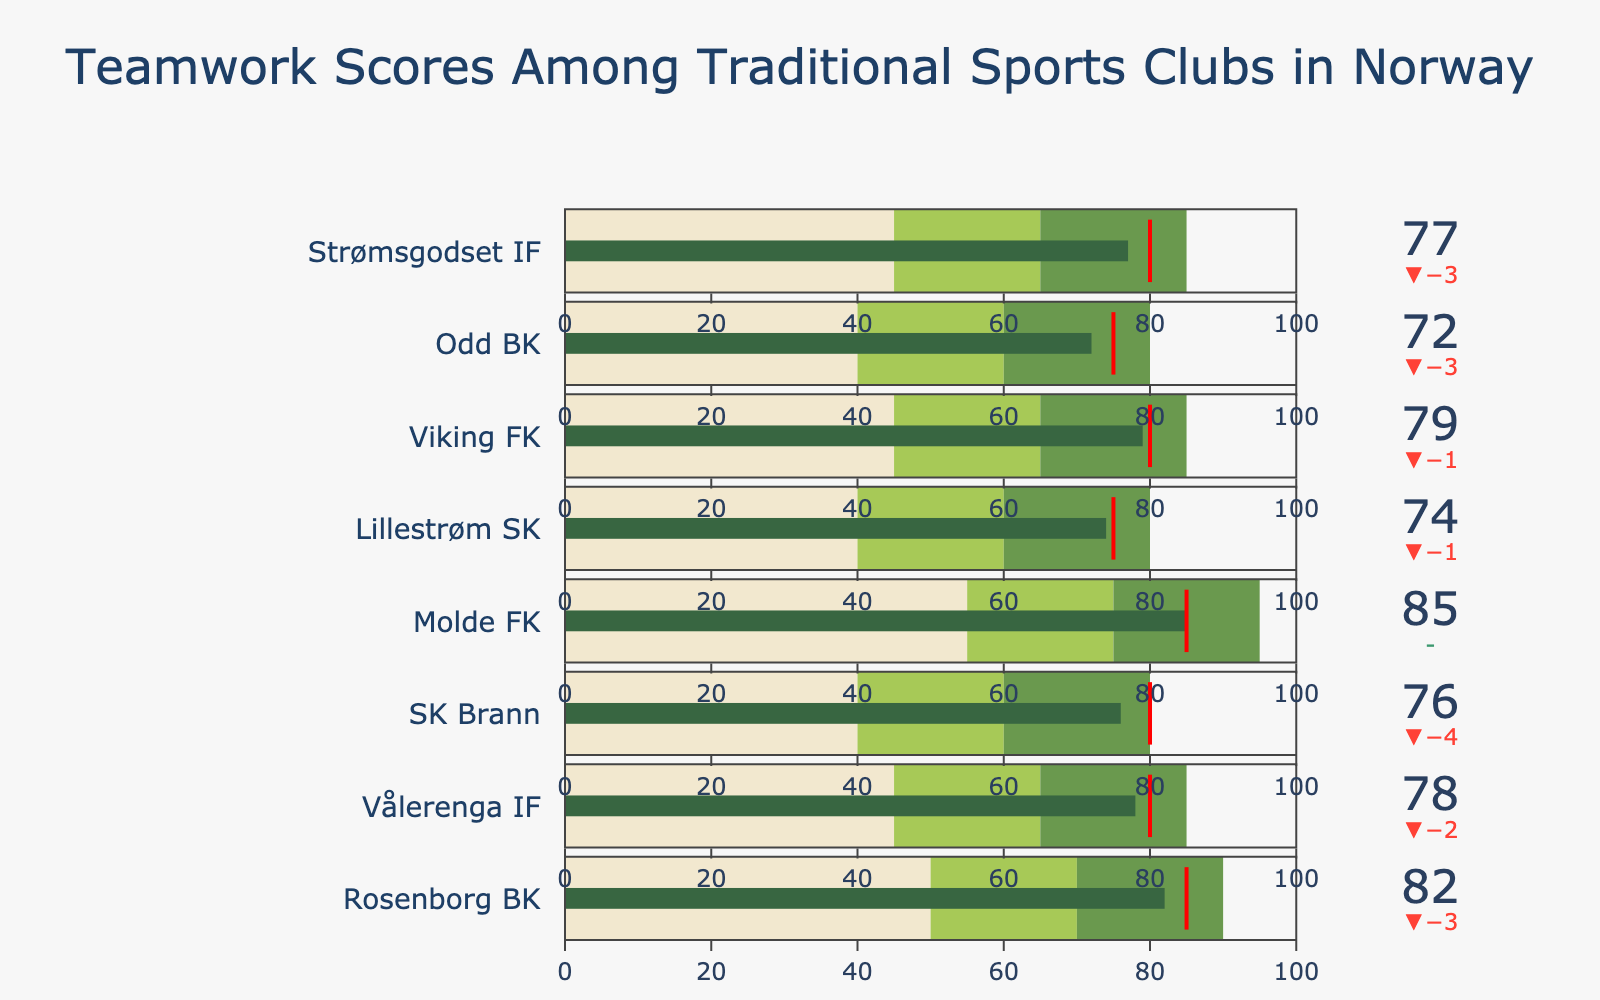What's the title of the chart? The title of the chart is written at the top in a slightly larger and bold font. It reads "Teamwork Scores Among Traditional Sports Clubs in Norway"
Answer: Teamwork Scores Among Traditional Sports Clubs in Norway What is Viking FK's actual teamwork score? Viking FK's actual score is visually shown on the bar as a number in the green bar region of the bullet chart for Viking FK.
Answer: 79 How many clubs have met or exceeded their target teamwork scores? We need to compare the actual scores with the target scores for each club. If the actual score is equal to or higher than the target, count that club. Molde FK and none of the others meet/exceed their target scores.
Answer: 1 Which clubs have actual teamwork scores in the 70-80 range? Identifying clubs listed on the chart and checking their actual scores in the 70-80 range, Vålerenga IF, SK Brann, Lillestrøm SK, and Strømsgodset IF fall within this range.
Answer: Vålerenga IF, SK Brann, Lillestrøm SK, Strømsgodset IF What's the difference between Molde FK's actual and target scores? Find Molde FK on the chart and subtract the target score from the actual score. Molde FK: 85 (actual) - 85 (target) = 0.
Answer: 0 Which club has the highest actual teamwork score? Look at each club’s actual score in the chart. Molde FK and Rosenborg BK have the highest actual scores, both at 85.
Answer: Molde FK & Rosenborg BK What is the average target teamwork score across all clubs? Sum the target scores of all clubs and then divide by number of clubs: (85 + 80 + 80 + 85 + 75 + 80 + 75 + 80) / 8 = 80
Answer: 80 Is the actual score of SK Brann in the target range? Check SK Brann's actual score and its ranges. SK Brann's actual is 76 which is in the target range (60-80) but below the target score of 80.
Answer: No What is the range of teamwork scores for SK Brann? The ranges for SK Brann are shown in the bullet chart below the actual score and summarized values in the table. The ranges are 40 (low end), 60 (middle range), and 80 (high end).
Answer: 40 to 80 Which clubs' actual teamwork scores are below their first range's upper bound? To answer this, check each club's actual score and compare it with the first range upper bound. Odd BK's actual 72 is below their first range of 75's upper bound.
Answer: Odd BK 